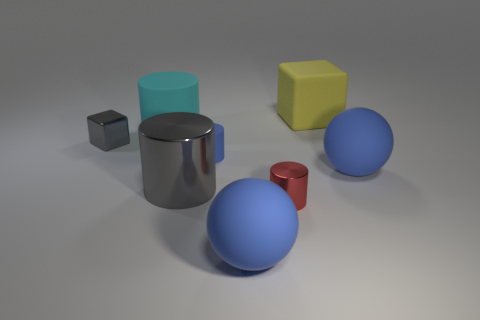What color is the large object that is both behind the big gray cylinder and on the left side of the large block?
Provide a succinct answer. Cyan. What number of other things are the same material as the small blue cylinder?
Your response must be concise. 4. Is the number of tiny red rubber things less than the number of yellow rubber cubes?
Ensure brevity in your answer.  Yes. Is the big block made of the same material as the big sphere that is behind the red shiny object?
Offer a terse response. Yes. There is a matte object that is behind the large cyan rubber cylinder; what shape is it?
Ensure brevity in your answer.  Cube. Is there anything else that has the same color as the tiny block?
Your response must be concise. Yes. Is the number of large matte blocks that are to the right of the large gray metal cylinder less than the number of large matte things?
Your answer should be very brief. Yes. What number of other rubber things have the same size as the yellow matte object?
Ensure brevity in your answer.  3. There is a tiny object that is the same color as the big metal object; what is its shape?
Offer a terse response. Cube. What shape is the large blue object that is in front of the large matte sphere on the right side of the cube behind the cyan matte object?
Make the answer very short. Sphere. 